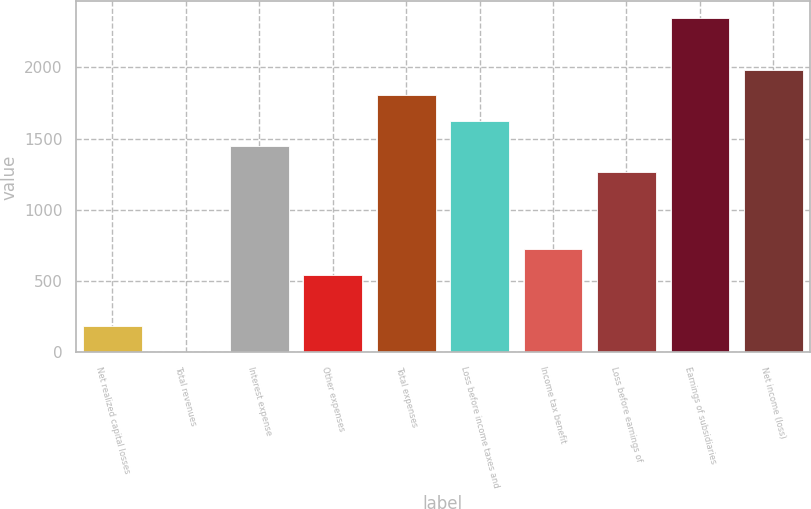Convert chart to OTSL. <chart><loc_0><loc_0><loc_500><loc_500><bar_chart><fcel>Net realized capital losses<fcel>Total revenues<fcel>Interest expense<fcel>Other expenses<fcel>Total expenses<fcel>Loss before income taxes and<fcel>Income tax benefit<fcel>Loss before earnings of<fcel>Earnings of subsidiaries<fcel>Net income (loss)<nl><fcel>185<fcel>5<fcel>1445<fcel>545<fcel>1805<fcel>1625<fcel>725<fcel>1265<fcel>2345<fcel>1985<nl></chart> 